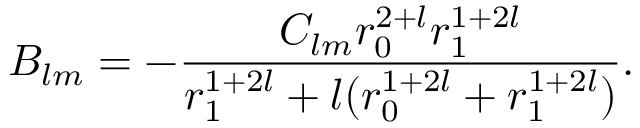Convert formula to latex. <formula><loc_0><loc_0><loc_500><loc_500>B _ { l m } = - \frac { C _ { l m } r _ { 0 } ^ { 2 + l } r _ { 1 } ^ { 1 + 2 l } } { r _ { 1 } ^ { 1 + 2 l } + l ( r _ { 0 } ^ { 1 + 2 l } + r _ { 1 } ^ { 1 + 2 l } ) } .</formula> 